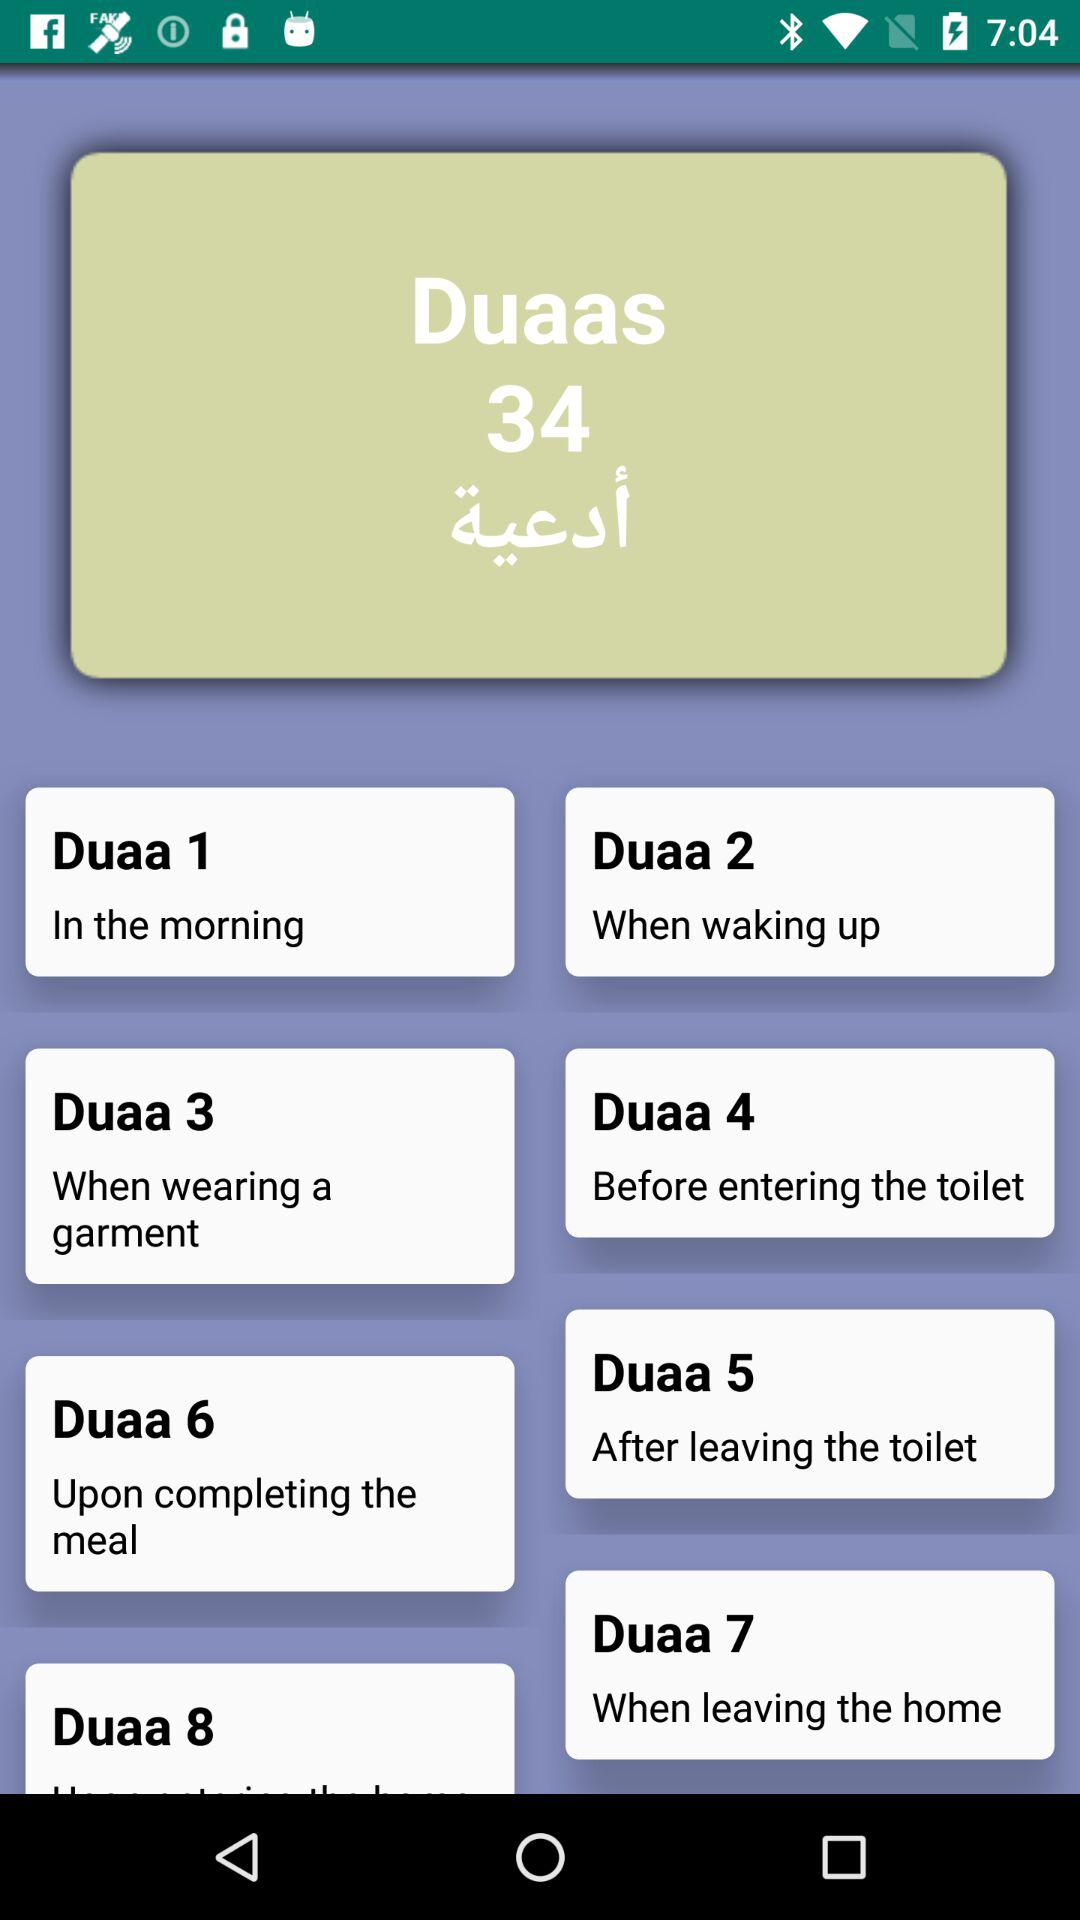What duaa should be recited after eating? After eating, "Duaa 6" should be recited. 